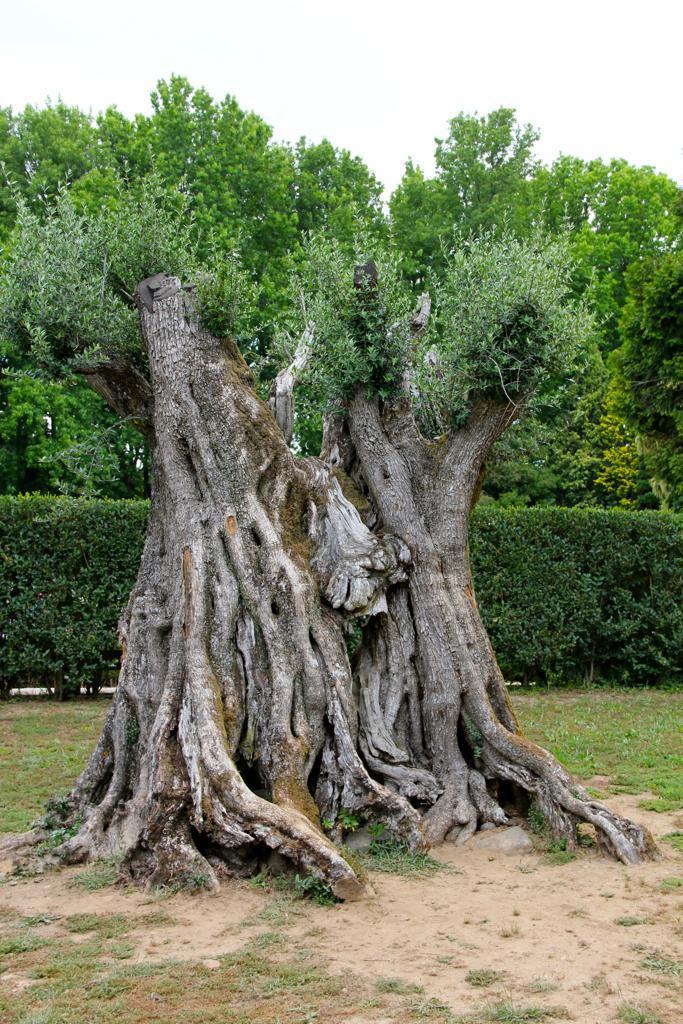Can you describe this image briefly? As we can see in the image there is a tree stem, grass, plants, trees and a sky. 